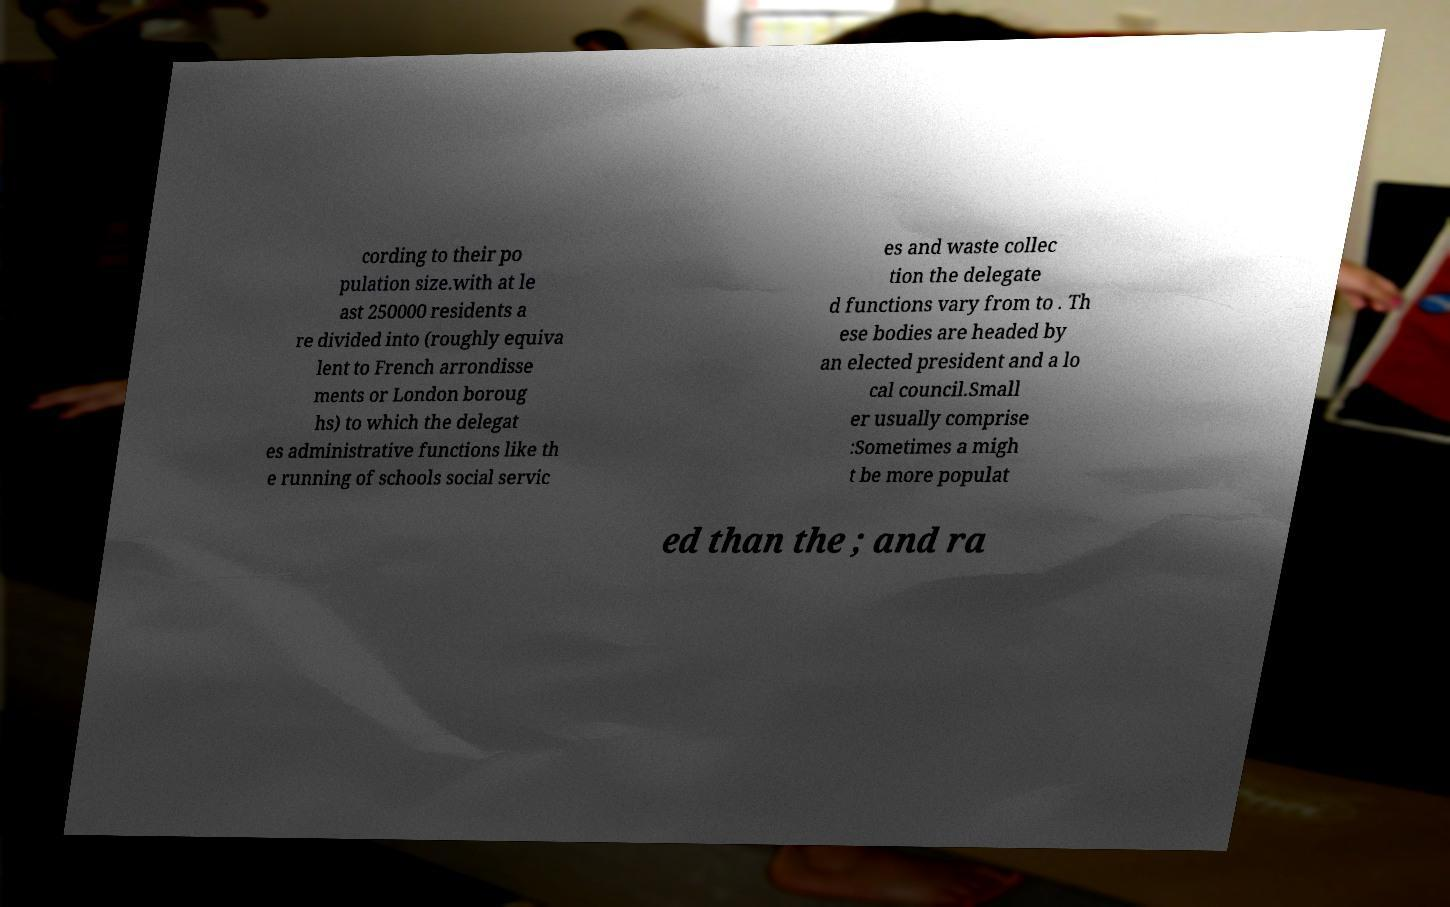For documentation purposes, I need the text within this image transcribed. Could you provide that? cording to their po pulation size.with at le ast 250000 residents a re divided into (roughly equiva lent to French arrondisse ments or London boroug hs) to which the delegat es administrative functions like th e running of schools social servic es and waste collec tion the delegate d functions vary from to . Th ese bodies are headed by an elected president and a lo cal council.Small er usually comprise :Sometimes a migh t be more populat ed than the ; and ra 